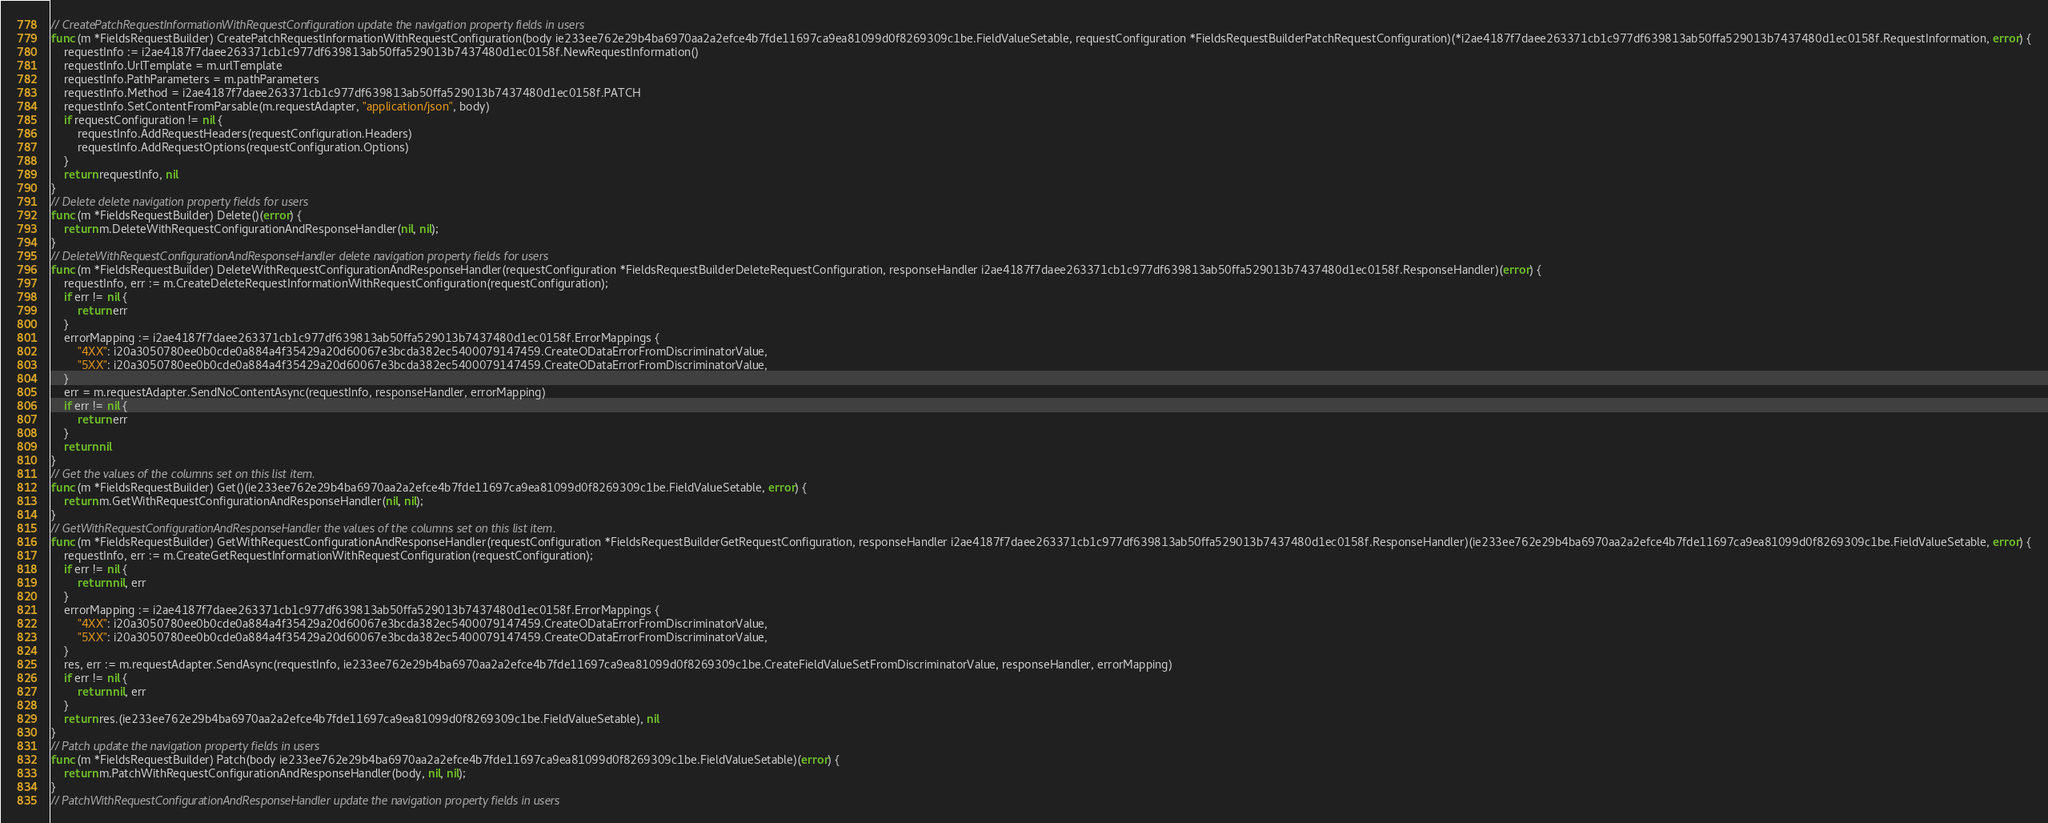Convert code to text. <code><loc_0><loc_0><loc_500><loc_500><_Go_>// CreatePatchRequestInformationWithRequestConfiguration update the navigation property fields in users
func (m *FieldsRequestBuilder) CreatePatchRequestInformationWithRequestConfiguration(body ie233ee762e29b4ba6970aa2a2efce4b7fde11697ca9ea81099d0f8269309c1be.FieldValueSetable, requestConfiguration *FieldsRequestBuilderPatchRequestConfiguration)(*i2ae4187f7daee263371cb1c977df639813ab50ffa529013b7437480d1ec0158f.RequestInformation, error) {
    requestInfo := i2ae4187f7daee263371cb1c977df639813ab50ffa529013b7437480d1ec0158f.NewRequestInformation()
    requestInfo.UrlTemplate = m.urlTemplate
    requestInfo.PathParameters = m.pathParameters
    requestInfo.Method = i2ae4187f7daee263371cb1c977df639813ab50ffa529013b7437480d1ec0158f.PATCH
    requestInfo.SetContentFromParsable(m.requestAdapter, "application/json", body)
    if requestConfiguration != nil {
        requestInfo.AddRequestHeaders(requestConfiguration.Headers)
        requestInfo.AddRequestOptions(requestConfiguration.Options)
    }
    return requestInfo, nil
}
// Delete delete navigation property fields for users
func (m *FieldsRequestBuilder) Delete()(error) {
    return m.DeleteWithRequestConfigurationAndResponseHandler(nil, nil);
}
// DeleteWithRequestConfigurationAndResponseHandler delete navigation property fields for users
func (m *FieldsRequestBuilder) DeleteWithRequestConfigurationAndResponseHandler(requestConfiguration *FieldsRequestBuilderDeleteRequestConfiguration, responseHandler i2ae4187f7daee263371cb1c977df639813ab50ffa529013b7437480d1ec0158f.ResponseHandler)(error) {
    requestInfo, err := m.CreateDeleteRequestInformationWithRequestConfiguration(requestConfiguration);
    if err != nil {
        return err
    }
    errorMapping := i2ae4187f7daee263371cb1c977df639813ab50ffa529013b7437480d1ec0158f.ErrorMappings {
        "4XX": i20a3050780ee0b0cde0a884a4f35429a20d60067e3bcda382ec5400079147459.CreateODataErrorFromDiscriminatorValue,
        "5XX": i20a3050780ee0b0cde0a884a4f35429a20d60067e3bcda382ec5400079147459.CreateODataErrorFromDiscriminatorValue,
    }
    err = m.requestAdapter.SendNoContentAsync(requestInfo, responseHandler, errorMapping)
    if err != nil {
        return err
    }
    return nil
}
// Get the values of the columns set on this list item.
func (m *FieldsRequestBuilder) Get()(ie233ee762e29b4ba6970aa2a2efce4b7fde11697ca9ea81099d0f8269309c1be.FieldValueSetable, error) {
    return m.GetWithRequestConfigurationAndResponseHandler(nil, nil);
}
// GetWithRequestConfigurationAndResponseHandler the values of the columns set on this list item.
func (m *FieldsRequestBuilder) GetWithRequestConfigurationAndResponseHandler(requestConfiguration *FieldsRequestBuilderGetRequestConfiguration, responseHandler i2ae4187f7daee263371cb1c977df639813ab50ffa529013b7437480d1ec0158f.ResponseHandler)(ie233ee762e29b4ba6970aa2a2efce4b7fde11697ca9ea81099d0f8269309c1be.FieldValueSetable, error) {
    requestInfo, err := m.CreateGetRequestInformationWithRequestConfiguration(requestConfiguration);
    if err != nil {
        return nil, err
    }
    errorMapping := i2ae4187f7daee263371cb1c977df639813ab50ffa529013b7437480d1ec0158f.ErrorMappings {
        "4XX": i20a3050780ee0b0cde0a884a4f35429a20d60067e3bcda382ec5400079147459.CreateODataErrorFromDiscriminatorValue,
        "5XX": i20a3050780ee0b0cde0a884a4f35429a20d60067e3bcda382ec5400079147459.CreateODataErrorFromDiscriminatorValue,
    }
    res, err := m.requestAdapter.SendAsync(requestInfo, ie233ee762e29b4ba6970aa2a2efce4b7fde11697ca9ea81099d0f8269309c1be.CreateFieldValueSetFromDiscriminatorValue, responseHandler, errorMapping)
    if err != nil {
        return nil, err
    }
    return res.(ie233ee762e29b4ba6970aa2a2efce4b7fde11697ca9ea81099d0f8269309c1be.FieldValueSetable), nil
}
// Patch update the navigation property fields in users
func (m *FieldsRequestBuilder) Patch(body ie233ee762e29b4ba6970aa2a2efce4b7fde11697ca9ea81099d0f8269309c1be.FieldValueSetable)(error) {
    return m.PatchWithRequestConfigurationAndResponseHandler(body, nil, nil);
}
// PatchWithRequestConfigurationAndResponseHandler update the navigation property fields in users</code> 